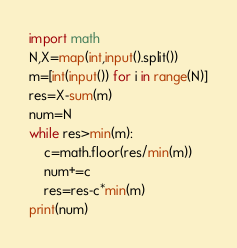<code> <loc_0><loc_0><loc_500><loc_500><_Python_>import math
N,X=map(int,input().split())
m=[int(input()) for i in range(N)]
res=X-sum(m)
num=N
while res>min(m):
    c=math.floor(res/min(m))
    num+=c
    res=res-c*min(m)
print(num)
</code> 